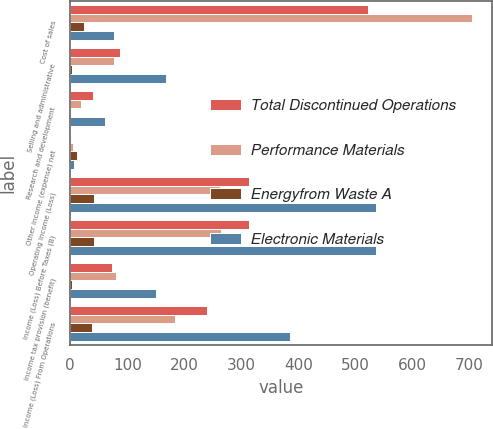<chart> <loc_0><loc_0><loc_500><loc_500><stacked_bar_chart><ecel><fcel>Cost of sales<fcel>Selling and administrative<fcel>Research and development<fcel>Other income (expense) net<fcel>Operating Income (Loss)<fcel>Income (Loss) Before Taxes (B)<fcel>Income tax provision (benefit)<fcel>Income (Loss) From Operations<nl><fcel>Total Discontinued Operations<fcel>521.6<fcel>87.7<fcel>40.8<fcel>2.2<fcel>313.7<fcel>313.6<fcel>73.4<fcel>240.2<nl><fcel>Performance Materials<fcel>704.5<fcel>76.6<fcel>19.6<fcel>4.2<fcel>262.6<fcel>264<fcel>80.5<fcel>183.5<nl><fcel>Energyfrom Waste A<fcel>24.6<fcel>2.8<fcel>0.9<fcel>12.7<fcel>41<fcel>41<fcel>3.4<fcel>37.6<nl><fcel>Electronic Materials<fcel>76.6<fcel>167.1<fcel>61.3<fcel>6.3<fcel>535.3<fcel>536.6<fcel>150.5<fcel>386.1<nl></chart> 